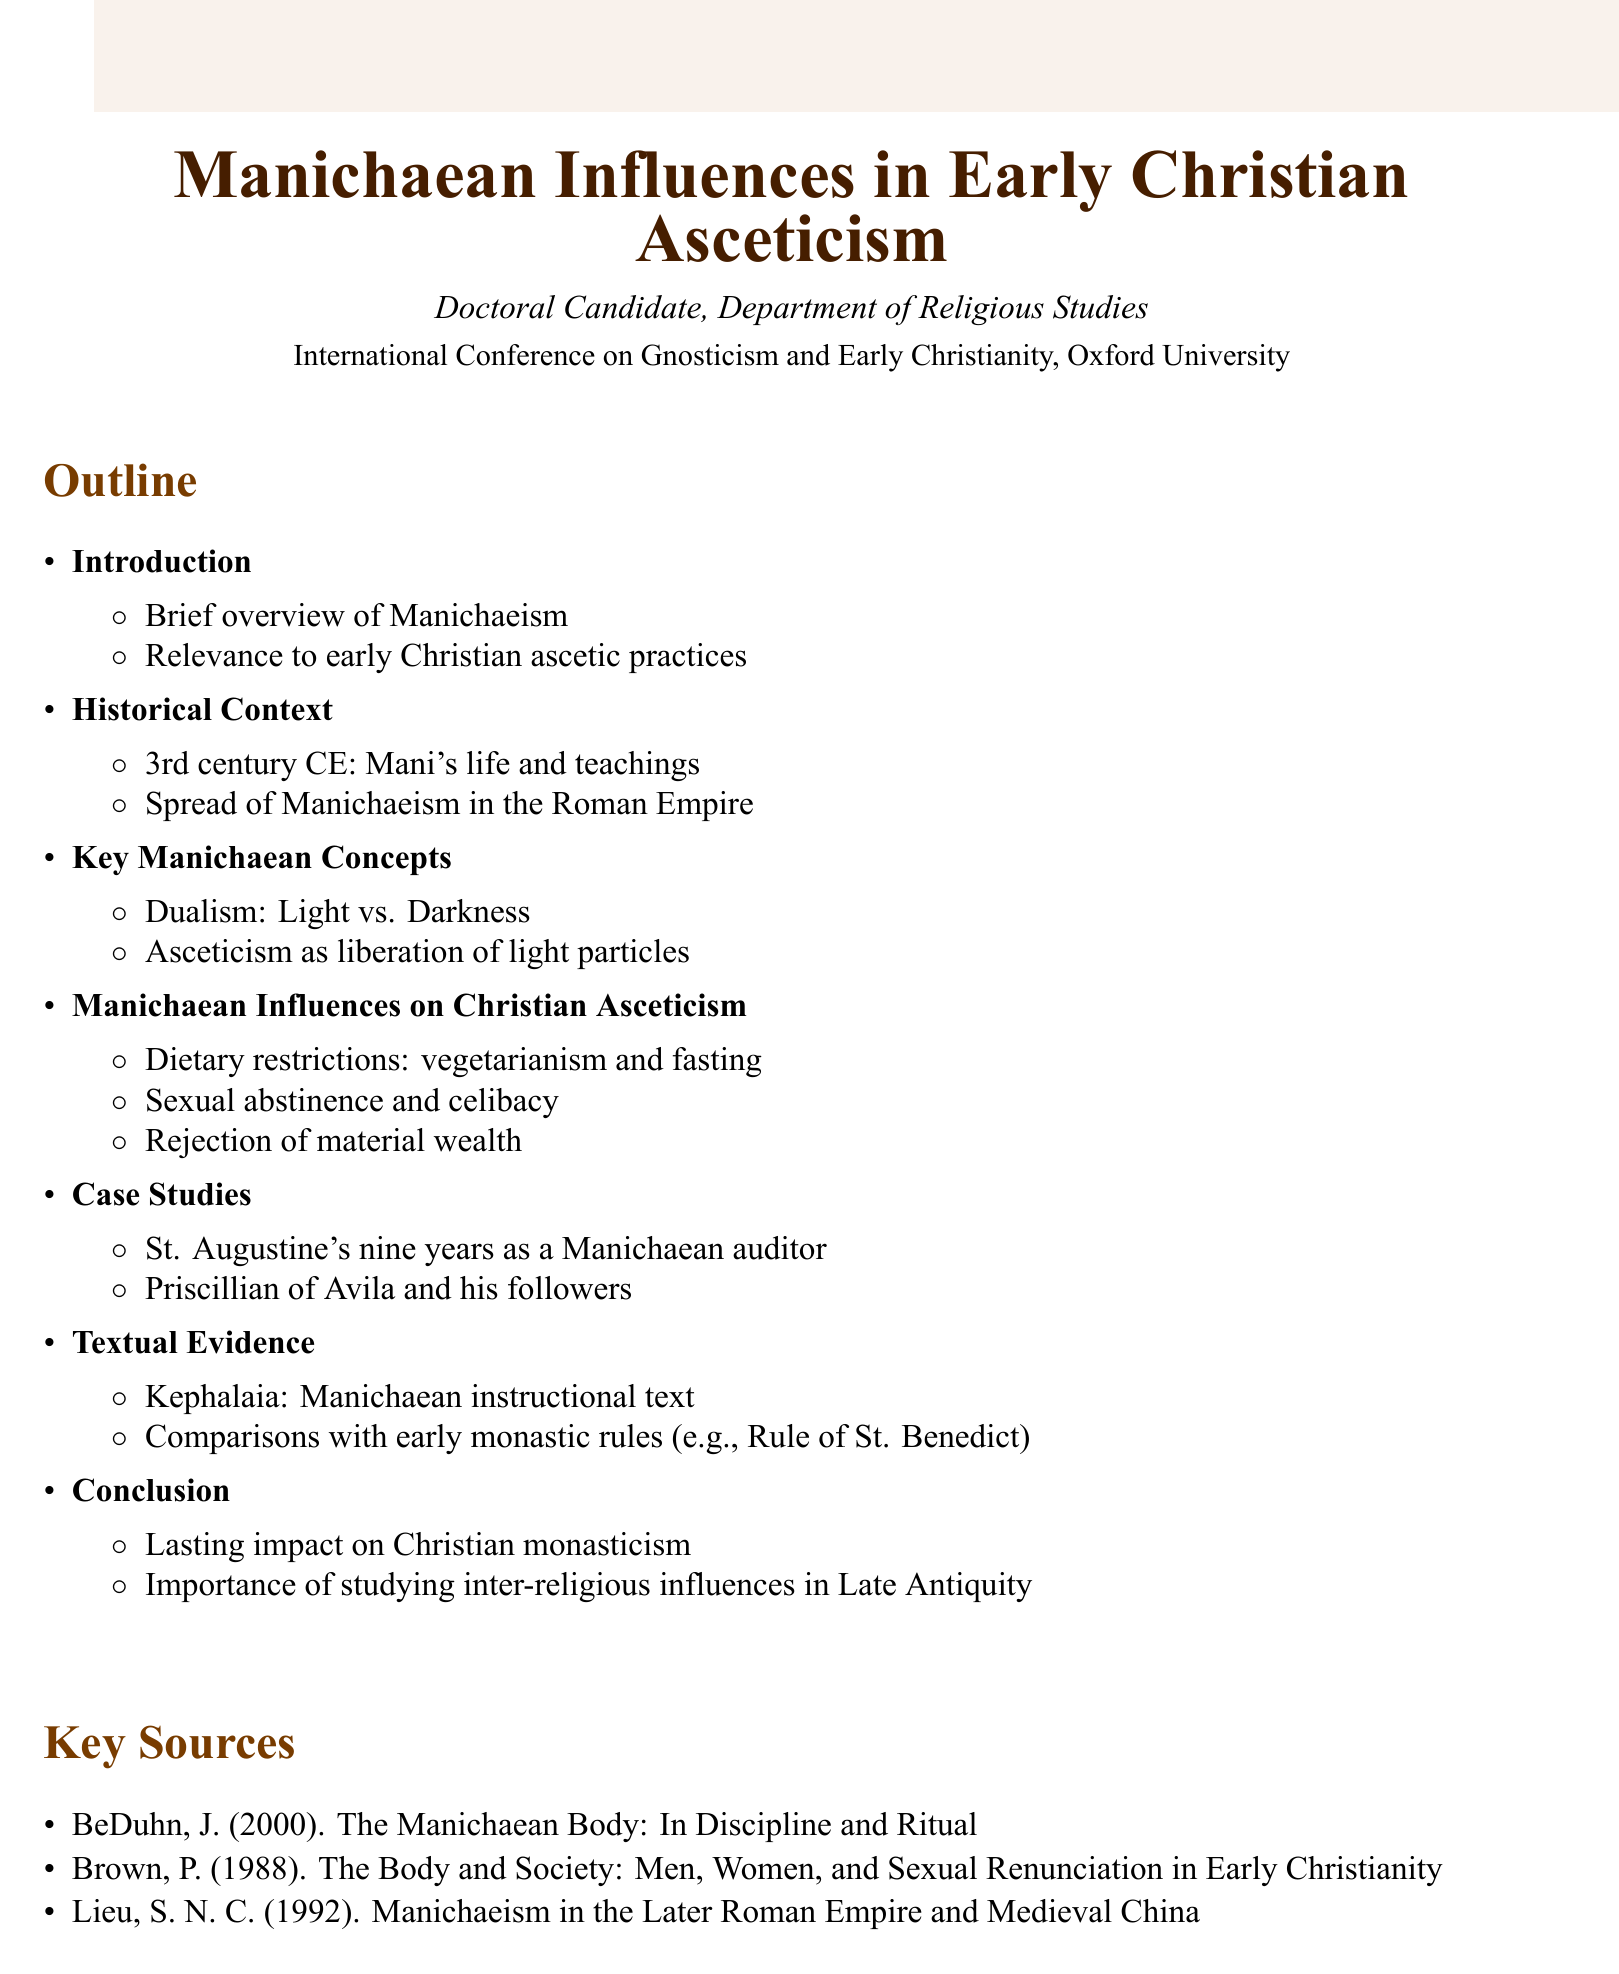What is the title of the presentation? The title is stated at the beginning of the document and is clearly labeled.
Answer: Manichaean Influences in Early Christian Asceticism Who is presenting the research? The document specifies the presenter in the introduction section.
Answer: Doctoral Candidate, Department of Religious Studies What century did Mani live in? The historical context section provides a specific date related to Mani's life.
Answer: 3rd century CE Name one key Manichaean concept discussed. The document lists important concepts in the section dedicated to Manichaean beliefs.
Answer: Dualism: Light vs. Darkness What dietary practice is mentioned as a Manichaean influence? The influences on Christian asceticism section includes specific practices linked to Manichaean thought.
Answer: Vegetarianism Which figure had nine years as a Manichaean auditor? The case studies section details significant individuals and their connections to Manichaeanism.
Answer: St. Augustine What is one source cited in the document? The key sources section lists authors and their works related to the research topic.
Answer: BeDuhn, J. (2000). The Manichaean Body: In Discipline and Ritual What is one conclusion drawn in the document? The conclusion section summarizes the impacts and importance of the findings presented.
Answer: Lasting impact on Christian monasticism 